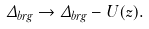Convert formula to latex. <formula><loc_0><loc_0><loc_500><loc_500>\Delta _ { b r g } \rightarrow \Delta _ { b r g } - U ( z ) .</formula> 